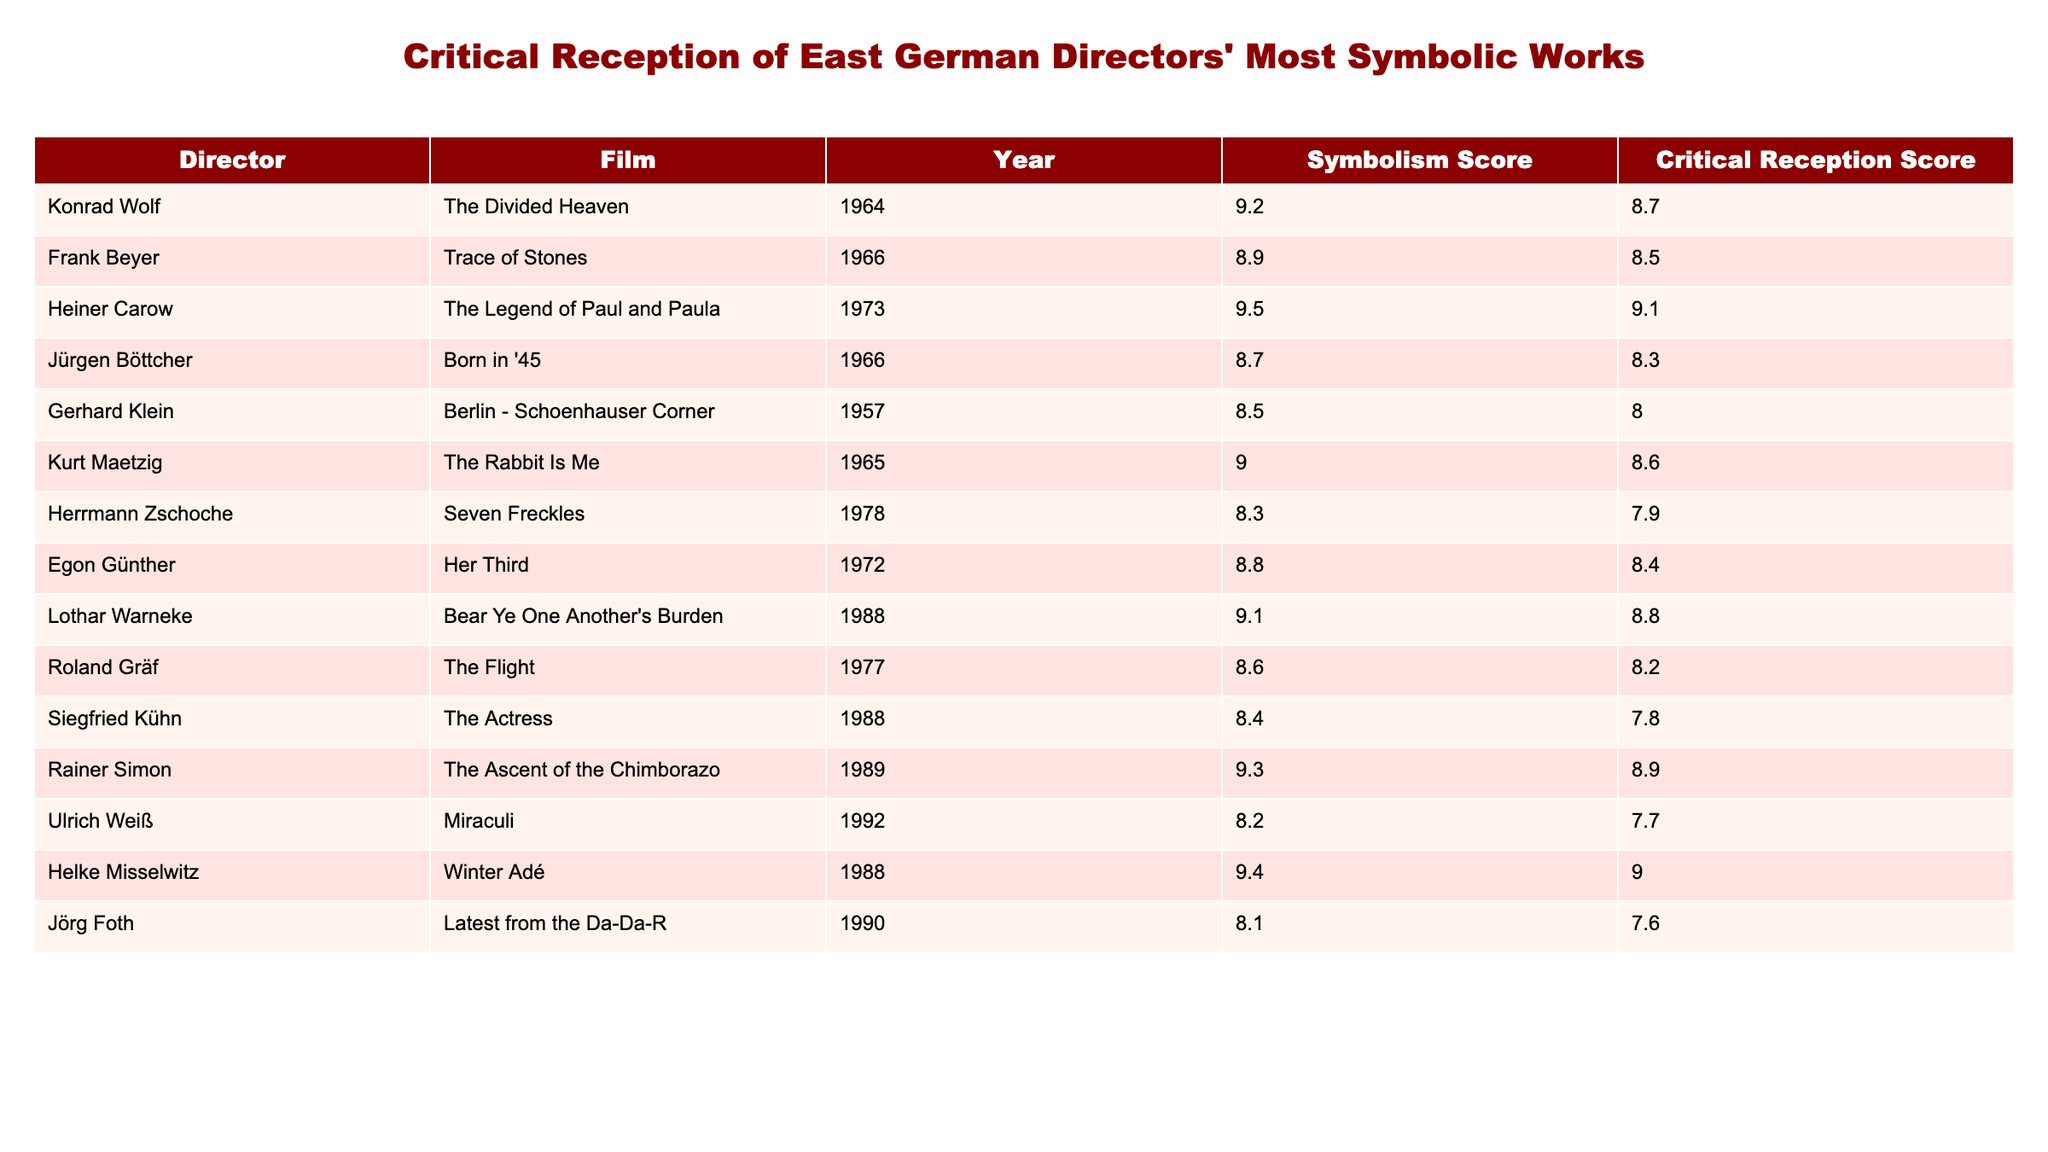What is the highest symbolism score among East German directors' films? The highest symbolism score in the table is 9.5, which belongs to Heiner Carow's film "The Legend of Paul and Paula."
Answer: 9.5 Which film by Frank Beyer has a critical reception score of 8.5? Frank Beyer's film "Trace of Stones," released in 1966, has a critical reception score of 8.5.
Answer: Trace of Stones What is the difference in critical reception scores between "The Ascent of the Chimborazo" and "Seven Freckles"? The critical reception score for "The Ascent of the Chimborazo" is 8.9 and for "Seven Freckles" it is 7.9. The difference is 8.9 - 7.9 = 1.0.
Answer: 1.0 What is the average symbolism score of films directed by directors with a score higher than 9.0? The films with a symbolism score higher than 9.0 are "The Legend of Paul and Paula" (9.5), "Winter Adé" (9.4), "The Ascent of the Chimborazo" (9.3), and "Bear Ye One Another's Burden" (9.1). Their total is 9.5 + 9.4 + 9.3 + 9.1 = 37.3, and the average is 37.3 / 4 = 9.325.
Answer: 9.325 Is it true that all films from the 1980s scored above 8 in critical reception? The films from the 1980s listed include "The Actress" (7.8), which has a critical reception score below 8. Therefore, the statement is false.
Answer: False What year did Konrad Wolf release his most symbolic film? Konrad Wolf released "The Divided Heaven," his most symbolic film with a score of 9.2, in the year 1964.
Answer: 1964 Which director has the lowest critical reception score, and what is that score? Siegfried Kühn has the lowest critical reception score at 7.8 for his film "The Actress."
Answer: 7.8 How many films in the table have a symbolism score of 8.8 or higher? The films with a symbolism score of 8.8 or higher are: "The Divided Heaven" (9.2), "Trace of Stones" (8.9), "The Legend of Paul and Paula" (9.5), "The Rabbit Is Me" (9.0), "Her Third" (8.8), "Bear Ye One Another's Burden" (9.1), "Winter Adé" (9.4), and "The Ascent of the Chimborazo" (9.3). That makes a total of 8 films.
Answer: 8 Determine the ranking of "The Flight" based on its critical reception score among the listed films. "The Flight" has a critical reception score of 8.2, ranking it 8th when compared to the other films in the table.
Answer: 8th 